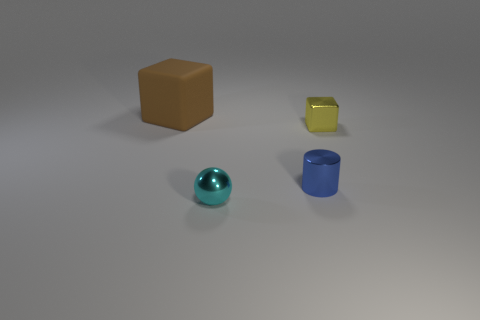Add 2 small cyan shiny cylinders. How many objects exist? 6 Subtract all spheres. How many objects are left? 3 Subtract 0 red cubes. How many objects are left? 4 Subtract all big blocks. Subtract all large brown blocks. How many objects are left? 2 Add 3 tiny blue things. How many tiny blue things are left? 4 Add 3 tiny brown cubes. How many tiny brown cubes exist? 3 